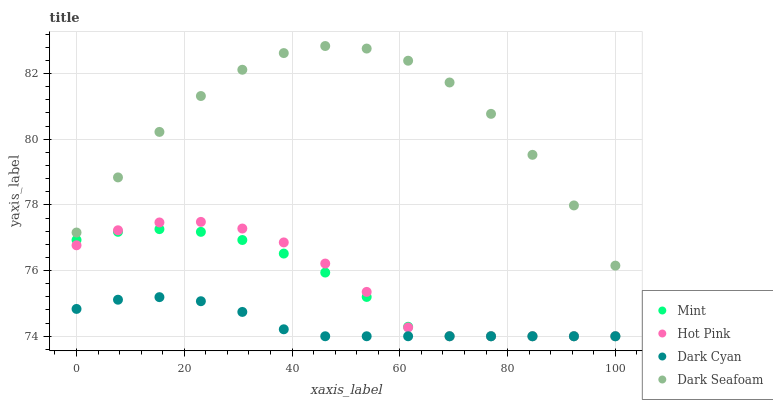Does Dark Cyan have the minimum area under the curve?
Answer yes or no. Yes. Does Dark Seafoam have the maximum area under the curve?
Answer yes or no. Yes. Does Hot Pink have the minimum area under the curve?
Answer yes or no. No. Does Hot Pink have the maximum area under the curve?
Answer yes or no. No. Is Dark Cyan the smoothest?
Answer yes or no. Yes. Is Dark Seafoam the roughest?
Answer yes or no. Yes. Is Hot Pink the smoothest?
Answer yes or no. No. Is Hot Pink the roughest?
Answer yes or no. No. Does Dark Cyan have the lowest value?
Answer yes or no. Yes. Does Dark Seafoam have the lowest value?
Answer yes or no. No. Does Dark Seafoam have the highest value?
Answer yes or no. Yes. Does Hot Pink have the highest value?
Answer yes or no. No. Is Dark Cyan less than Dark Seafoam?
Answer yes or no. Yes. Is Dark Seafoam greater than Mint?
Answer yes or no. Yes. Does Mint intersect Dark Cyan?
Answer yes or no. Yes. Is Mint less than Dark Cyan?
Answer yes or no. No. Is Mint greater than Dark Cyan?
Answer yes or no. No. Does Dark Cyan intersect Dark Seafoam?
Answer yes or no. No. 